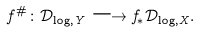Convert formula to latex. <formula><loc_0><loc_0><loc_500><loc_500>f ^ { \# } \colon \mathcal { D } _ { \log , Y } \longrightarrow f _ { \ast } \mathcal { D } _ { \log , X } .</formula> 